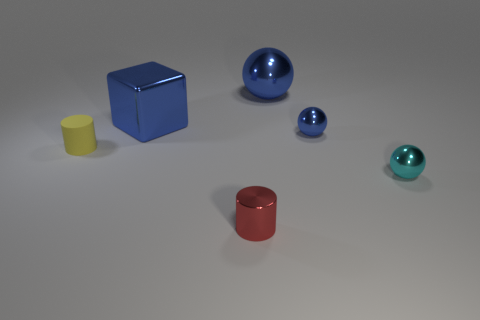Is the color of the cube the same as the large metal sphere? yes 